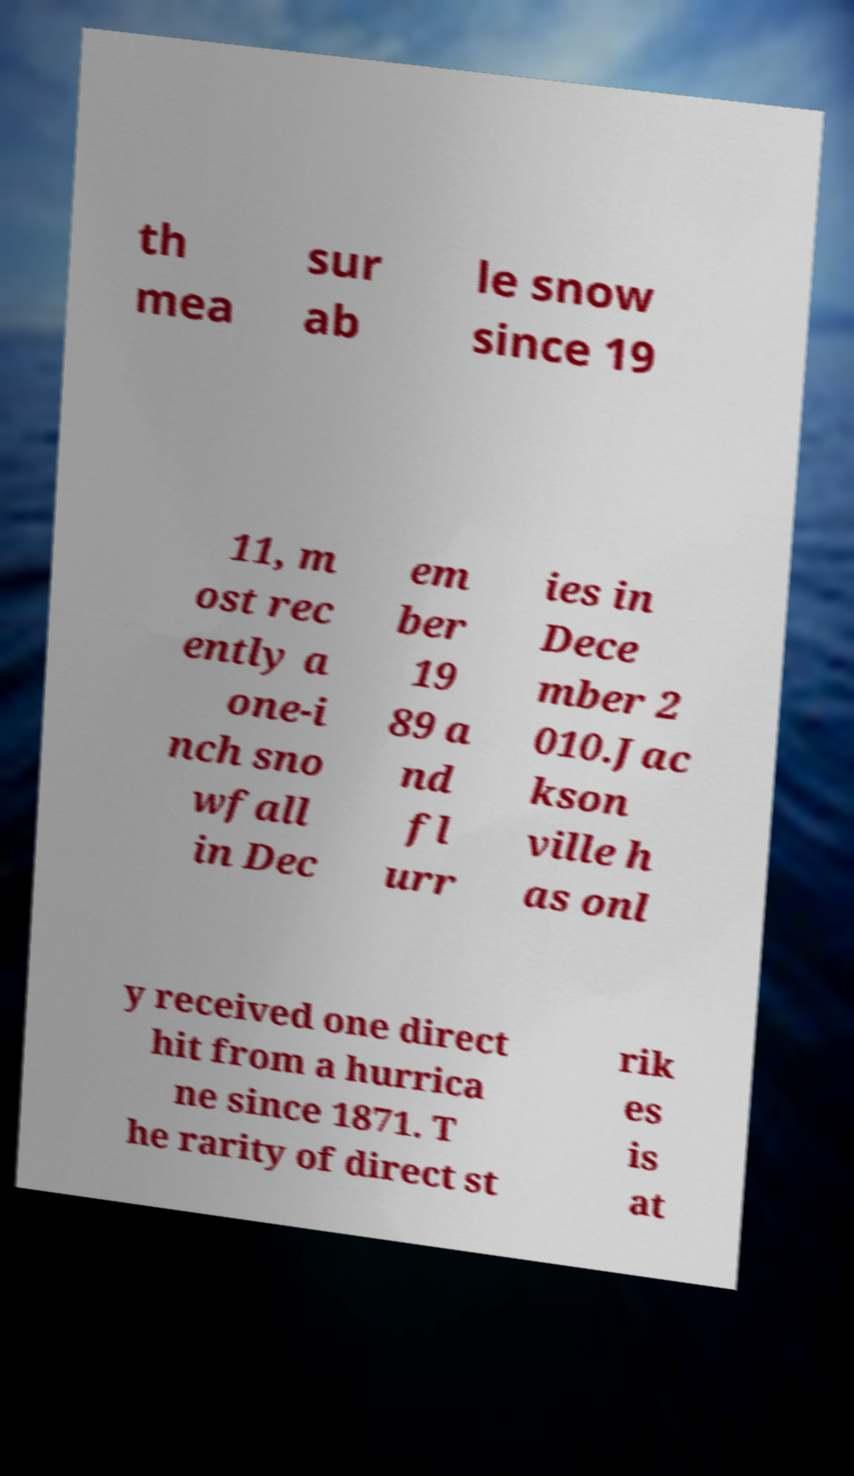What messages or text are displayed in this image? I need them in a readable, typed format. th mea sur ab le snow since 19 11, m ost rec ently a one-i nch sno wfall in Dec em ber 19 89 a nd fl urr ies in Dece mber 2 010.Jac kson ville h as onl y received one direct hit from a hurrica ne since 1871. T he rarity of direct st rik es is at 